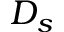Convert formula to latex. <formula><loc_0><loc_0><loc_500><loc_500>D _ { s }</formula> 